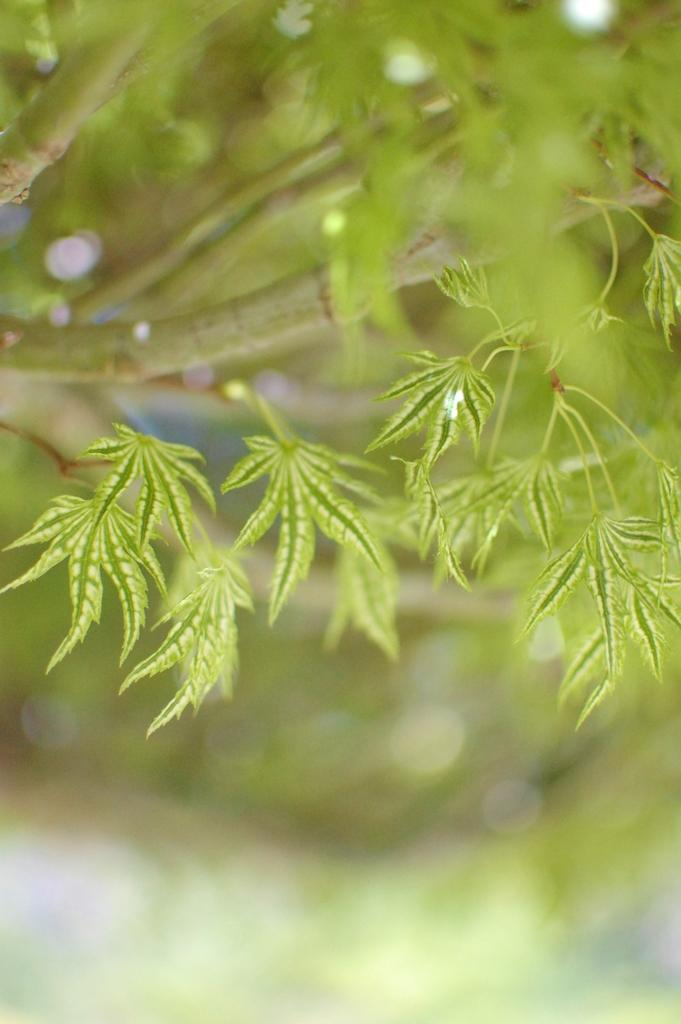What is the main subject of the picture? The main subject of the picture is the branches of a tree. What can be observed on the tree branches? There are green leaves on the tree branches. How many jellyfish can be seen swimming near the tree branches in the image? There are no jellyfish present in the image; it only features tree branches with green leaves. 